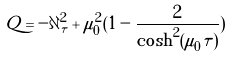Convert formula to latex. <formula><loc_0><loc_0><loc_500><loc_500>Q = - \partial _ { \tau } ^ { 2 } + \mu _ { 0 } ^ { 2 } ( 1 - \frac { 2 } { \cosh ^ { 2 } ( \mu _ { 0 } \tau ) } )</formula> 